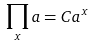<formula> <loc_0><loc_0><loc_500><loc_500>\prod _ { x } a = C a ^ { x }</formula> 